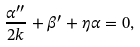Convert formula to latex. <formula><loc_0><loc_0><loc_500><loc_500>\frac { \alpha ^ { \prime \prime } } { 2 k } + \beta ^ { \prime } + \eta \alpha = 0 ,</formula> 